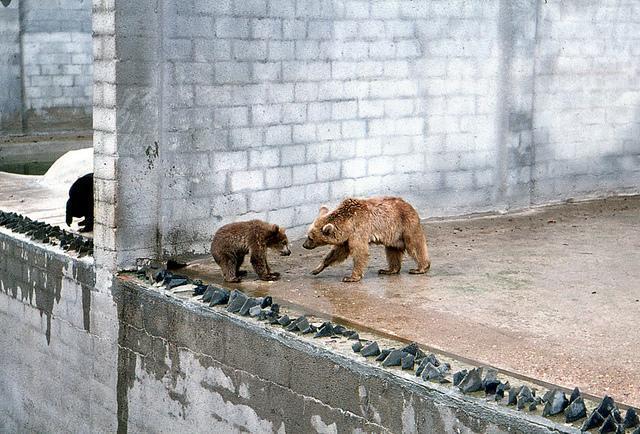What type of bears are in the foreground?
Pick the correct solution from the four options below to address the question.
Options: Black, polar, grizzly, panda. Grizzly. 